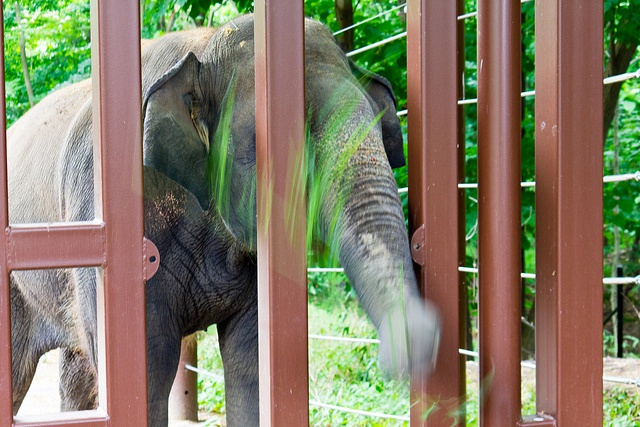Describe the objects in this image and their specific colors. I can see a elephant in brown, gray, black, darkgray, and lightgray tones in this image. 